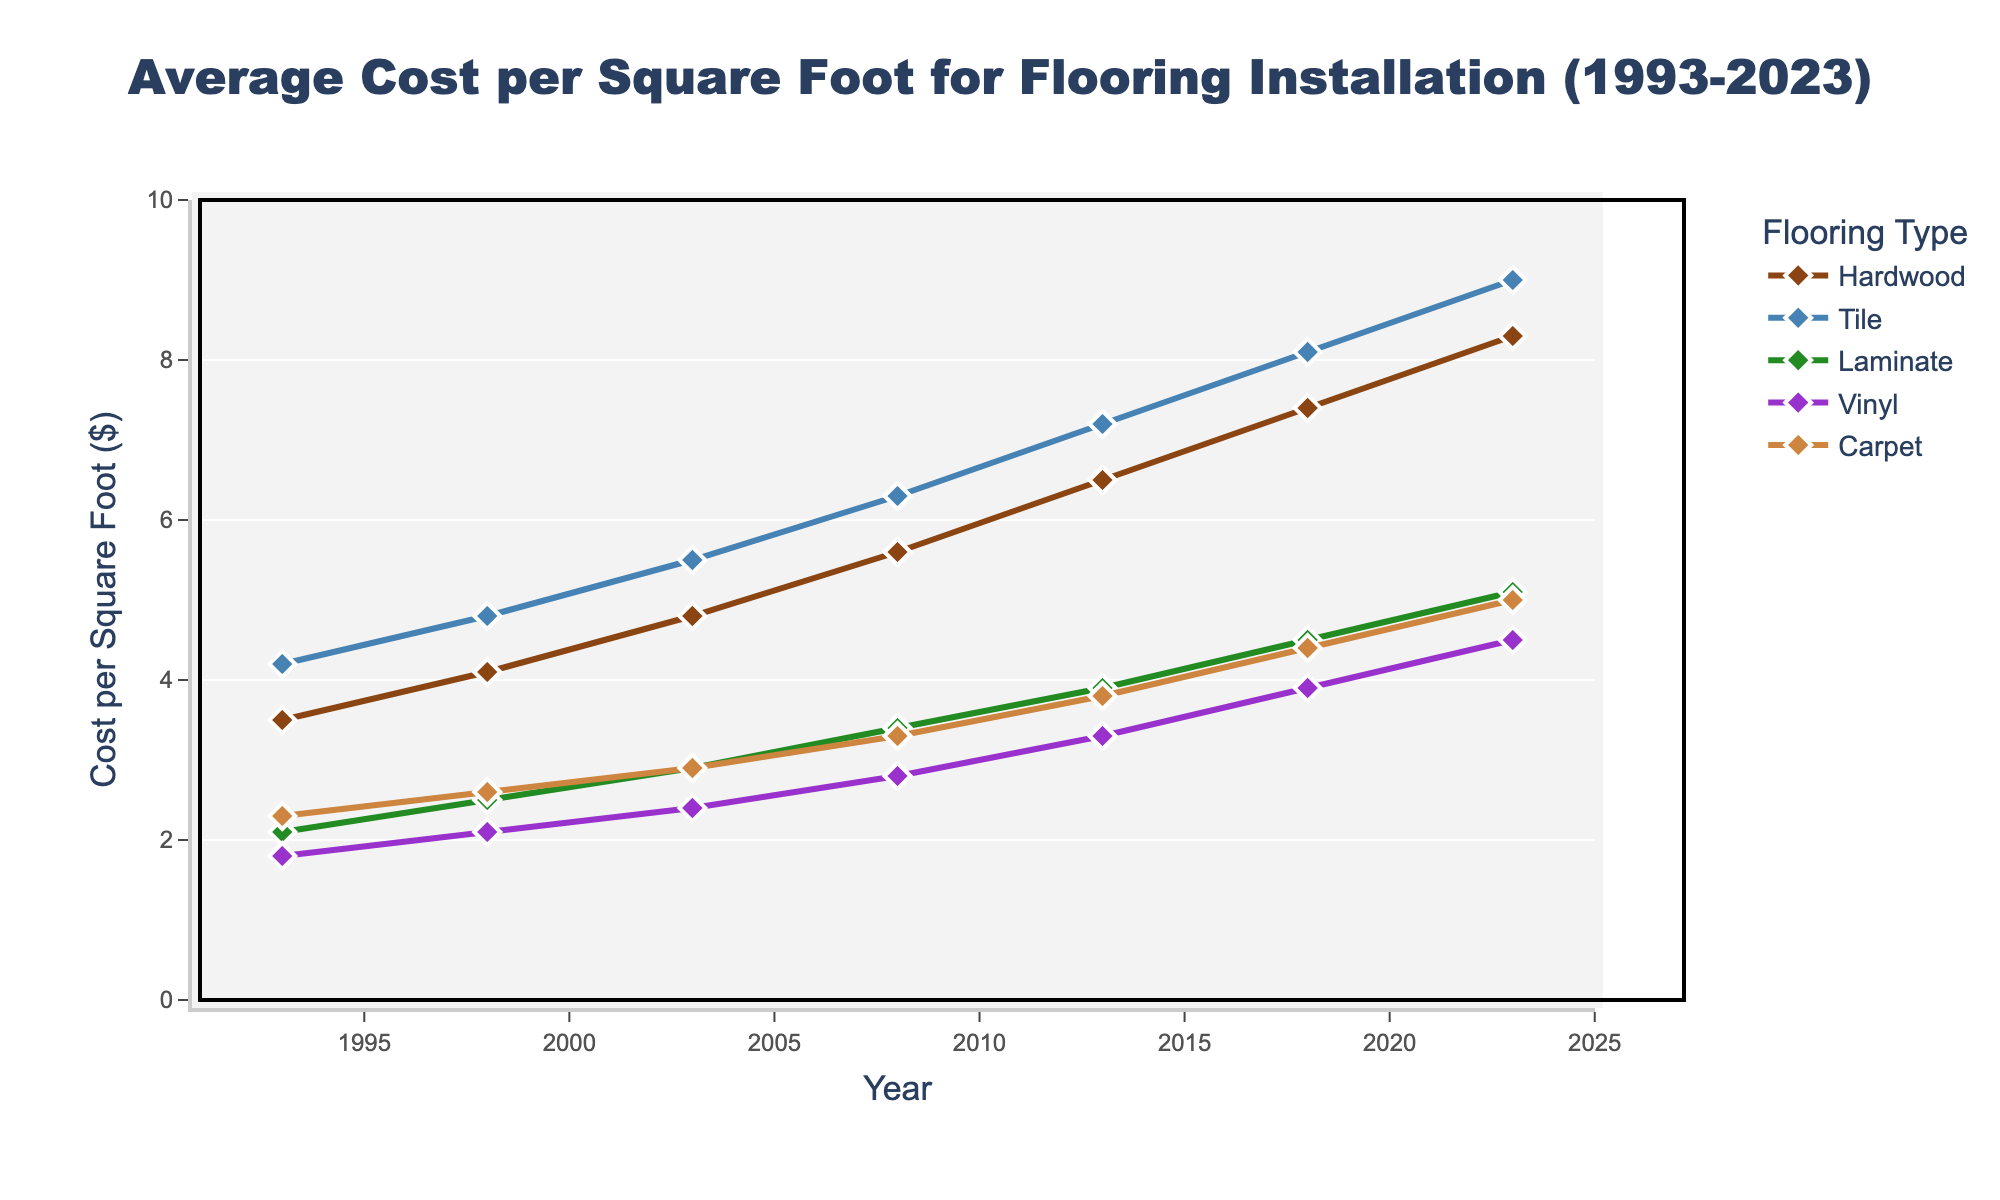What's the average cost of Vinyl and Carpet installation in 2008? In 2008, the cost for Vinyl is $2.80 and for Carpet is $3.30. Add these two amounts (2.80 + 3.30) and then divide by the number of items (2): (2.80 + 3.30) / 2 = 3.05
Answer: 3.05 Which flooring type had the biggest price increase between 1993 and 2023? Subtract the 1993 value from the 2023 value for each flooring type and compare the differences: Hardwood (8.30 - 3.50 = 4.80), Tile (9.00 - 4.20 = 4.80), Laminate (5.10 - 2.10 = 3.00), Vinyl (4.50 - 1.80 = 2.70), Carpet (5.00 - 2.30 = 2.70). The biggest increase is a tie between Hardwood and Tile, both with an increase of 4.80.
Answer: Hardwood and Tile Between 2013 and 2018, which flooring type experienced the highest rate of cost increase? Calculate the rate of increase between 2013 and 2018 for each type: Hardwood ((7.40 - 6.50) / 6.50) = 0.1385, Tile ((8.10 - 7.20) / 7.20) = 0.125, Laminate ((4.50 - 3.90) / 3.90) = 0.1538, Vinyl ((3.90 - 3.30) / 3.30) = 0.1818, Carpet ((4.40 - 3.80) / 3.80) = 0.1579. Vinyl has the highest rate with approximately 0.1818, which is about 18.18%.
Answer: Vinyl Which flooring type had the smallest increase in cost from 2003 to 2008? Calculate the difference in cost from 2003 to 2008 for each type: Hardwood (5.60 - 4.80) = 0.80, Tile (6.30 - 5.50) = 0.80, Laminate (3.40 - 2.90) = 0.50, Vinyl (2.80 - 2.40) = 0.40, Carpet (3.30 - 2.90) = 0.40. Both Vinyl and Carpet had the smallest increase of 0.40.
Answer: Vinyl and Carpet What is the total cost of installing 10 square feet of Tile and 15 square feet of Laminate in 2023? Multiply the cost per square foot by the number of square feet for each type and sum the totals: Tile (9.00 * 10) + Laminate (5.10 * 15). This calculates to 90 + 76.50 = 166.50.
Answer: 166.50 By how much did the cost of Hardwood increase between 1993 and 2018, and how does this compare to the increase for Carpet over the same period? Calculate the increase for Hardwood (7.40 - 3.50) = 3.90 and for Carpet (4.40 - 2.30) = 2.10. Compare each: 3.90 - 2.10 = 1.80. Hardwood's increase is 1.80 more than Carpet's.
Answer: 1.80 What was the average cost per square foot for all flooring types in 2023? Sum the costs of all flooring types in 2023: 8.30 + 9.00 + 5.10 + 4.50 + 5.00 = 31.90. Then divide by the number of types (5): 31.90 / 5 = 6.38.
Answer: 6.38 Which flooring type had the least cost fluctuation from 1993 to 2023? Calculate the range (maximum - minimum) for each type: Hardwood (8.30 - 3.50 = 4.80), Tile (9.00 - 4.20 = 4.80), Laminate (5.10 - 2.10 = 3.00), Vinyl (4.50 - 1.80 = 2.70), Carpet (5.00 - 2.30 = 2.70). Vinyl and Carpet had the least fluctuation with a range of 2.70.
Answer: Vinyl and Carpet 